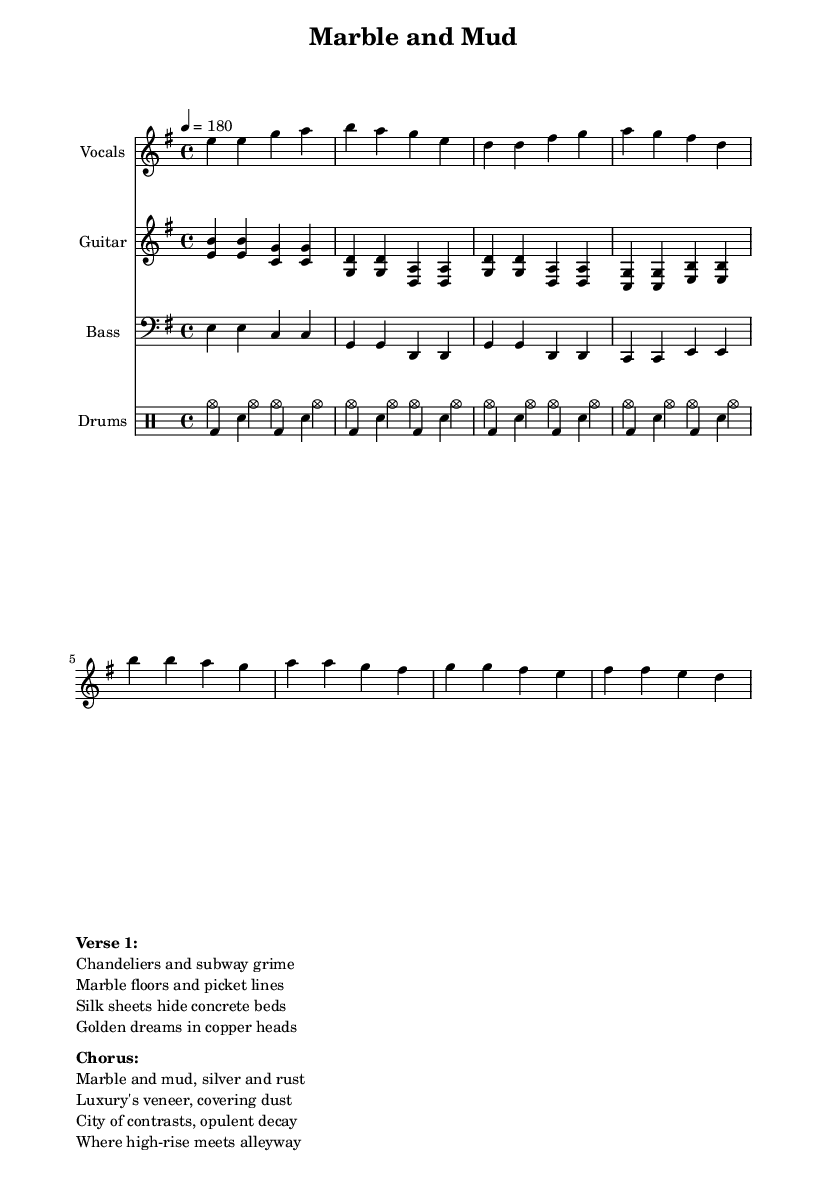What is the key signature of this music? The key signature is indicated at the beginning of the score, where it shows one sharp. This means it is in the key of E minor.
Answer: E minor What is the time signature of this music? The time signature is noted at the start of the sheet music and is written in the form of a fraction. Here it shows a 4 over 4 pattern, meaning there are four beats in each measure.
Answer: 4/4 What is the tempo marking of this music? The tempo marking appears in the score indicated by '4 = 180', which refers to the tempo of the piece. This means there should be 180 quarter note beats per minute.
Answer: 180 What is the predominant instrument used for rhythm in this song? By analyzing the various staves present in the score, it can be seen that the drum staff is explicitly included for rhythm, while the electric guitar and bass mainly support the harmonic structure. Therefore, the drums serve as the primary rhythmic instrument.
Answer: Drums How many measures are in the verse section? The verse section is indicated clearly in the vocal line subdivision where it shows four measures in total. By counting the groupings, we can confirm that there are indeed four separate measures dedicated to the verse.
Answer: 4 What is the lyrical contrast depicted in this song? The lyrics provide a juxtaposition between luxury and the harsher realities of city life. Terms such as 'Marble and mud' and 'golden dreams in copper heads' illustrate this contrast, highlighting opulence versus grit.
Answer: Opulence and grit What does the chorus suggest about the themes in the song? The chorus encapsulates the central themes of the song, specifically focusing on the disparity between luxurious living and underlying decay. It emphasizes the city as a place filled with contradictions, resonating with the punk ethos of challenging societal norms.
Answer: Contradictions in city life 